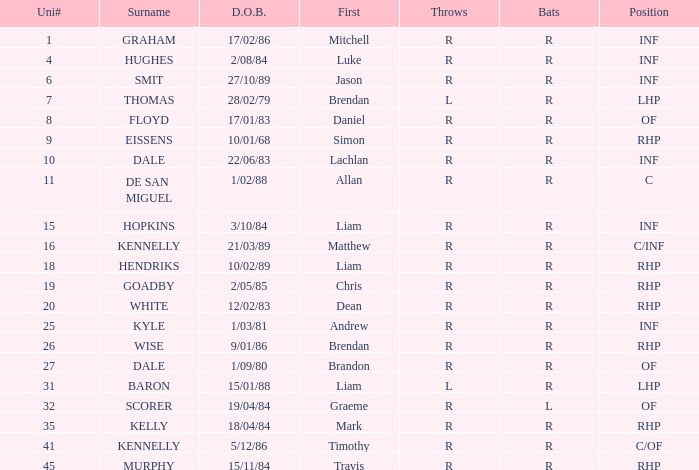Which batter has a uni# of 31? R. 